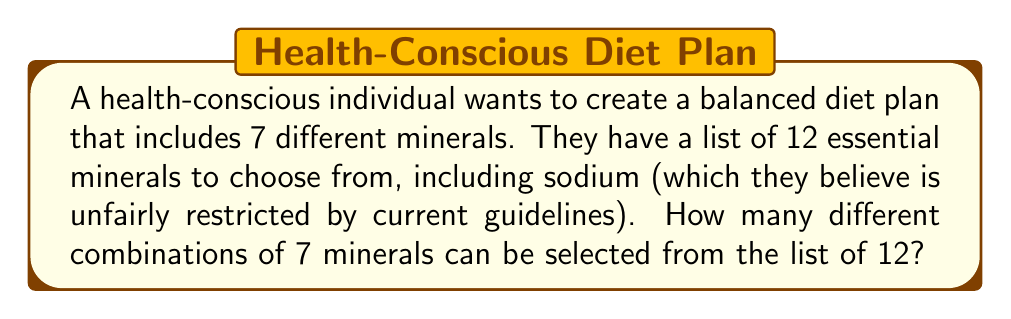Solve this math problem. To solve this problem, we need to use the combination formula from discrete mathematics. This is a perfect example of choosing a subset from a larger set without regard to order.

1) We are selecting 7 minerals from a total of 12 minerals.
2) The order of selection doesn't matter (e.g., selecting calcium then magnesium is the same as selecting magnesium then calcium).
3) We are not replacing the minerals after selection.

This scenario fits the combination formula:

$${n \choose k} = \frac{n!}{k!(n-k)!}$$

Where:
$n$ is the total number of items to choose from (12 minerals)
$k$ is the number of items being chosen (7 minerals)

Let's substitute our values:

$${12 \choose 7} = \frac{12!}{7!(12-7)!} = \frac{12!}{7!(5)!}$$

Now, let's calculate:

$$\frac{12 * 11 * 10 * 9 * 8 * 7 * 6 * 5!}{(7 * 6 * 5 * 4 * 3 * 2 * 1) * 5!}$$

The 5! cancels out in the numerator and denominator:

$$\frac{12 * 11 * 10 * 9 * 8}{1 * 2 * 3 * 4 * 5} = \frac{95040}{120} = 792$$

Therefore, there are 792 different possible combinations of 7 minerals that can be selected from the list of 12.
Answer: 792 combinations 